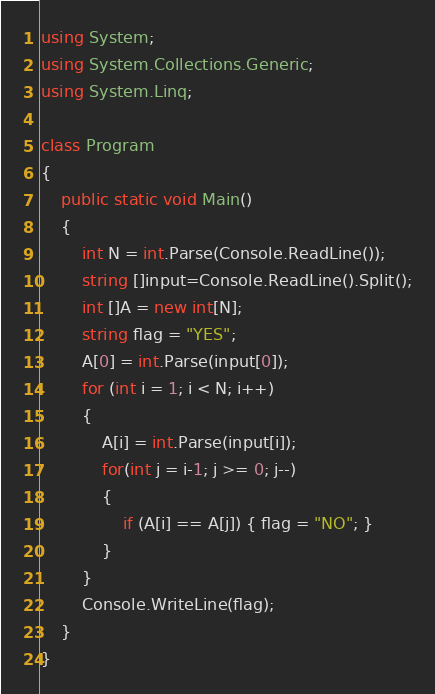Convert code to text. <code><loc_0><loc_0><loc_500><loc_500><_C#_>using System;
using System.Collections.Generic;
using System.Linq;

class Program
{
    public static void Main()
    {
        int N = int.Parse(Console.ReadLine());
        string []input=Console.ReadLine().Split();
        int []A = new int[N];
        string flag = "YES";
        A[0] = int.Parse(input[0]);
        for (int i = 1; i < N; i++)
        {
            A[i] = int.Parse(input[i]);
            for(int j = i-1; j >= 0; j--)
            {
                if (A[i] == A[j]) { flag = "NO"; }
            }
        }
        Console.WriteLine(flag);
    }
}</code> 